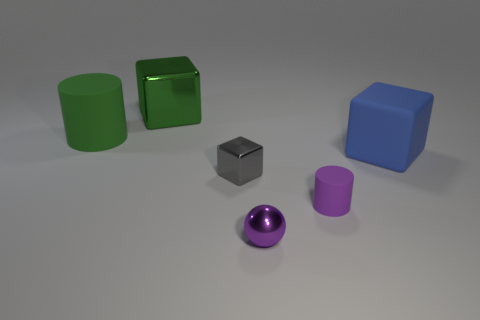Is the material of the big thing to the right of the tiny purple metal sphere the same as the green cylinder?
Your answer should be very brief. Yes. What number of things are brown matte cylinders or tiny purple matte things?
Keep it short and to the point. 1. What is the size of the green metallic object that is the same shape as the gray metal object?
Ensure brevity in your answer.  Large. The sphere has what size?
Offer a very short reply. Small. Is the number of matte objects that are to the right of the big rubber cylinder greater than the number of purple metallic spheres?
Make the answer very short. Yes. There is a thing that is left of the green metal cube; does it have the same color as the metallic sphere in front of the matte block?
Provide a succinct answer. No. What material is the small purple sphere in front of the large block that is to the left of the small purple thing behind the small purple shiny ball?
Give a very brief answer. Metal. Are there more large shiny objects than tiny objects?
Your answer should be very brief. No. Is there any other thing that is the same color as the metal ball?
Your answer should be compact. Yes. What is the size of the gray cube that is the same material as the purple ball?
Make the answer very short. Small. 